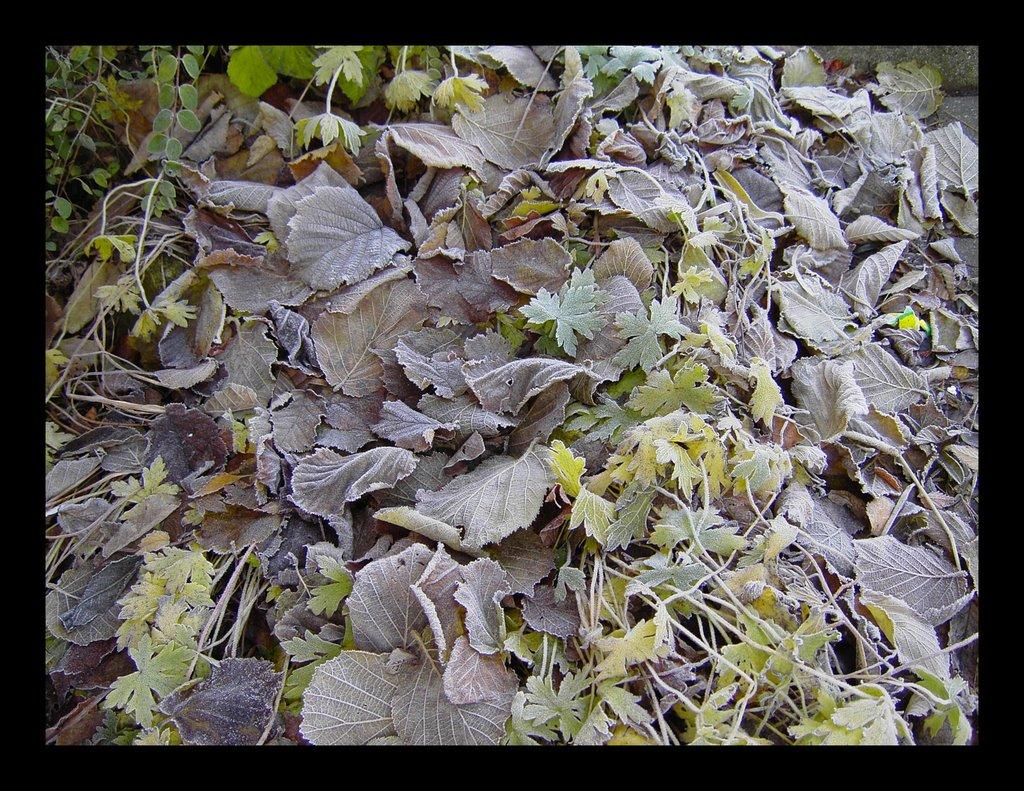What is visible in the foreground of the image? There are leaves and plants in the foreground of the image. Can you describe the plants in the foreground? The plants in the foreground are not specified, but they are present along with the leaves. How many rings can be seen on the duck in the image? There is no duck present in the image, and therefore no rings can be seen on it. 